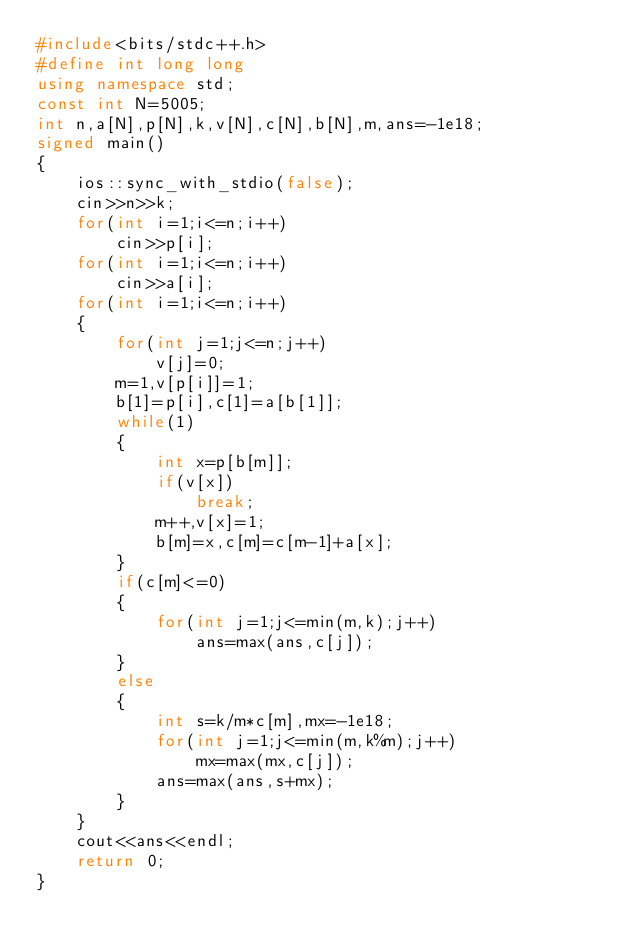<code> <loc_0><loc_0><loc_500><loc_500><_C++_>#include<bits/stdc++.h>
#define int long long
using namespace std;
const int N=5005;
int n,a[N],p[N],k,v[N],c[N],b[N],m,ans=-1e18;
signed main()
{
	ios::sync_with_stdio(false);
	cin>>n>>k;
	for(int i=1;i<=n;i++)
		cin>>p[i];
	for(int i=1;i<=n;i++)
		cin>>a[i];
	for(int i=1;i<=n;i++)
	{
		for(int j=1;j<=n;j++)
			v[j]=0;
		m=1,v[p[i]]=1;
		b[1]=p[i],c[1]=a[b[1]];
		while(1)
		{
			int x=p[b[m]];
			if(v[x])
				break;
			m++,v[x]=1;
			b[m]=x,c[m]=c[m-1]+a[x];
		}
		if(c[m]<=0)
		{
			for(int j=1;j<=min(m,k);j++)
				ans=max(ans,c[j]);
		}
		else
		{
			int s=k/m*c[m],mx=-1e18;
			for(int j=1;j<=min(m,k%m);j++)
				mx=max(mx,c[j]);
			ans=max(ans,s+mx);
		}
	}
	cout<<ans<<endl;
	return 0;
}</code> 